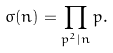Convert formula to latex. <formula><loc_0><loc_0><loc_500><loc_500>\sigma ( n ) = \prod _ { p ^ { 2 } | n } p .</formula> 